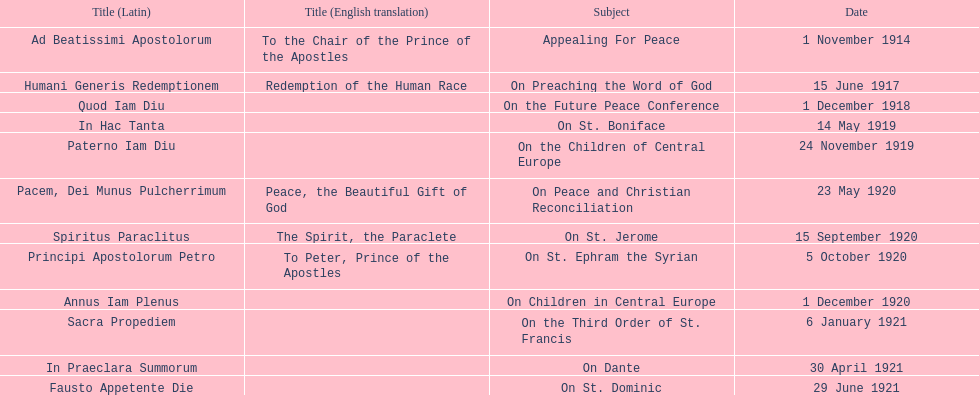Other than january how many encyclicals were in 1921? 2. 